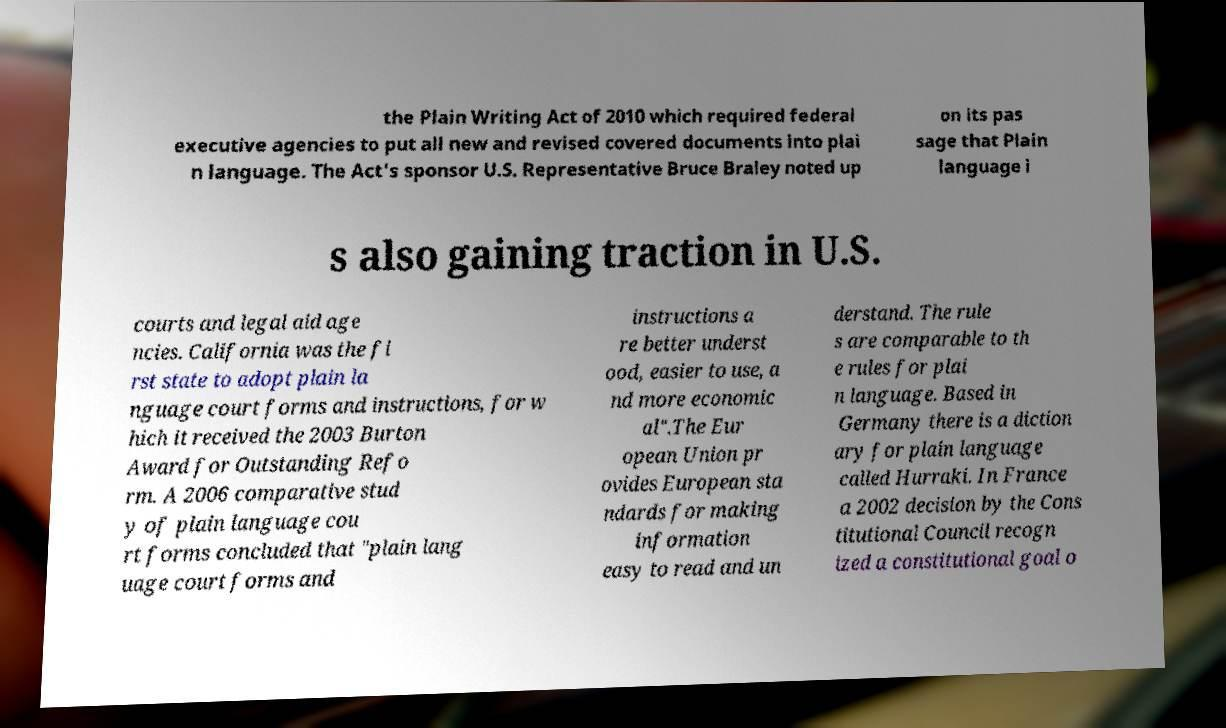For documentation purposes, I need the text within this image transcribed. Could you provide that? the Plain Writing Act of 2010 which required federal executive agencies to put all new and revised covered documents into plai n language. The Act's sponsor U.S. Representative Bruce Braley noted up on its pas sage that Plain language i s also gaining traction in U.S. courts and legal aid age ncies. California was the fi rst state to adopt plain la nguage court forms and instructions, for w hich it received the 2003 Burton Award for Outstanding Refo rm. A 2006 comparative stud y of plain language cou rt forms concluded that "plain lang uage court forms and instructions a re better underst ood, easier to use, a nd more economic al".The Eur opean Union pr ovides European sta ndards for making information easy to read and un derstand. The rule s are comparable to th e rules for plai n language. Based in Germany there is a diction ary for plain language called Hurraki. In France a 2002 decision by the Cons titutional Council recogn ized a constitutional goal o 